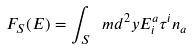Convert formula to latex. <formula><loc_0><loc_0><loc_500><loc_500>F _ { S } ( E ) = \int _ { S } \ m d ^ { 2 } y E ^ { a } _ { i } \tau ^ { i } n _ { a }</formula> 